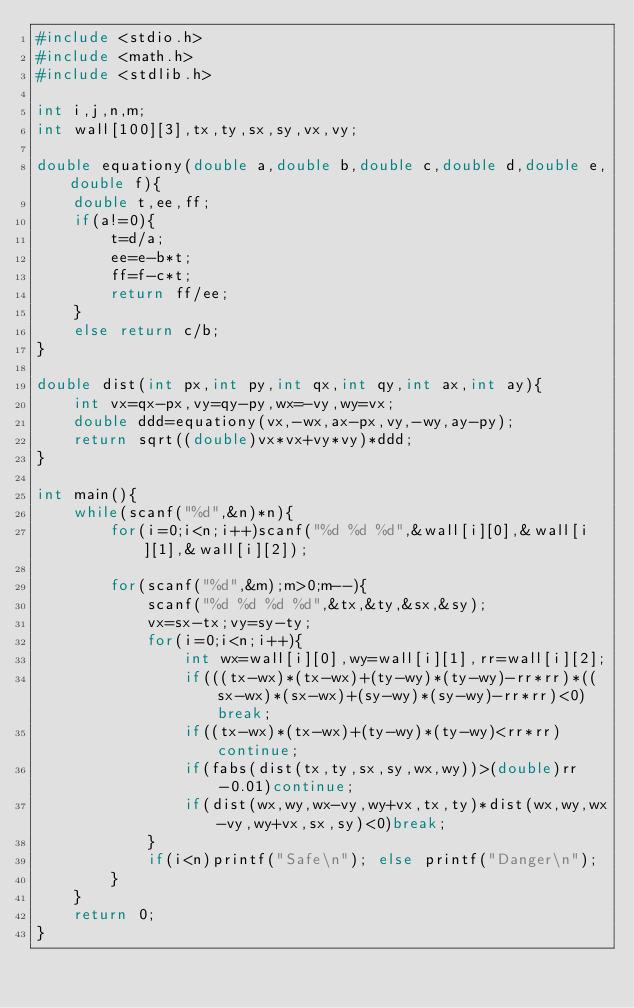Convert code to text. <code><loc_0><loc_0><loc_500><loc_500><_C_>#include <stdio.h>
#include <math.h>
#include <stdlib.h>

int i,j,n,m;
int wall[100][3],tx,ty,sx,sy,vx,vy;

double equationy(double a,double b,double c,double d,double e,double f){
	double t,ee,ff;
	if(a!=0){
		t=d/a;
		ee=e-b*t;
		ff=f-c*t;
		return ff/ee;
	}
	else return c/b;
}

double dist(int px,int py,int qx,int qy,int ax,int ay){
	int vx=qx-px,vy=qy-py,wx=-vy,wy=vx;
	double ddd=equationy(vx,-wx,ax-px,vy,-wy,ay-py);
	return sqrt((double)vx*vx+vy*vy)*ddd;
}

int main(){
	while(scanf("%d",&n)*n){
		for(i=0;i<n;i++)scanf("%d %d %d",&wall[i][0],&wall[i][1],&wall[i][2]);

		for(scanf("%d",&m);m>0;m--){
			scanf("%d %d %d %d",&tx,&ty,&sx,&sy);
			vx=sx-tx;vy=sy-ty;
			for(i=0;i<n;i++){
				int wx=wall[i][0],wy=wall[i][1],rr=wall[i][2];
				if(((tx-wx)*(tx-wx)+(ty-wy)*(ty-wy)-rr*rr)*((sx-wx)*(sx-wx)+(sy-wy)*(sy-wy)-rr*rr)<0)break;
				if((tx-wx)*(tx-wx)+(ty-wy)*(ty-wy)<rr*rr)continue;
				if(fabs(dist(tx,ty,sx,sy,wx,wy))>(double)rr-0.01)continue;
				if(dist(wx,wy,wx-vy,wy+vx,tx,ty)*dist(wx,wy,wx-vy,wy+vx,sx,sy)<0)break;
			}
			if(i<n)printf("Safe\n"); else printf("Danger\n");
		}
	}
	return 0;
}</code> 